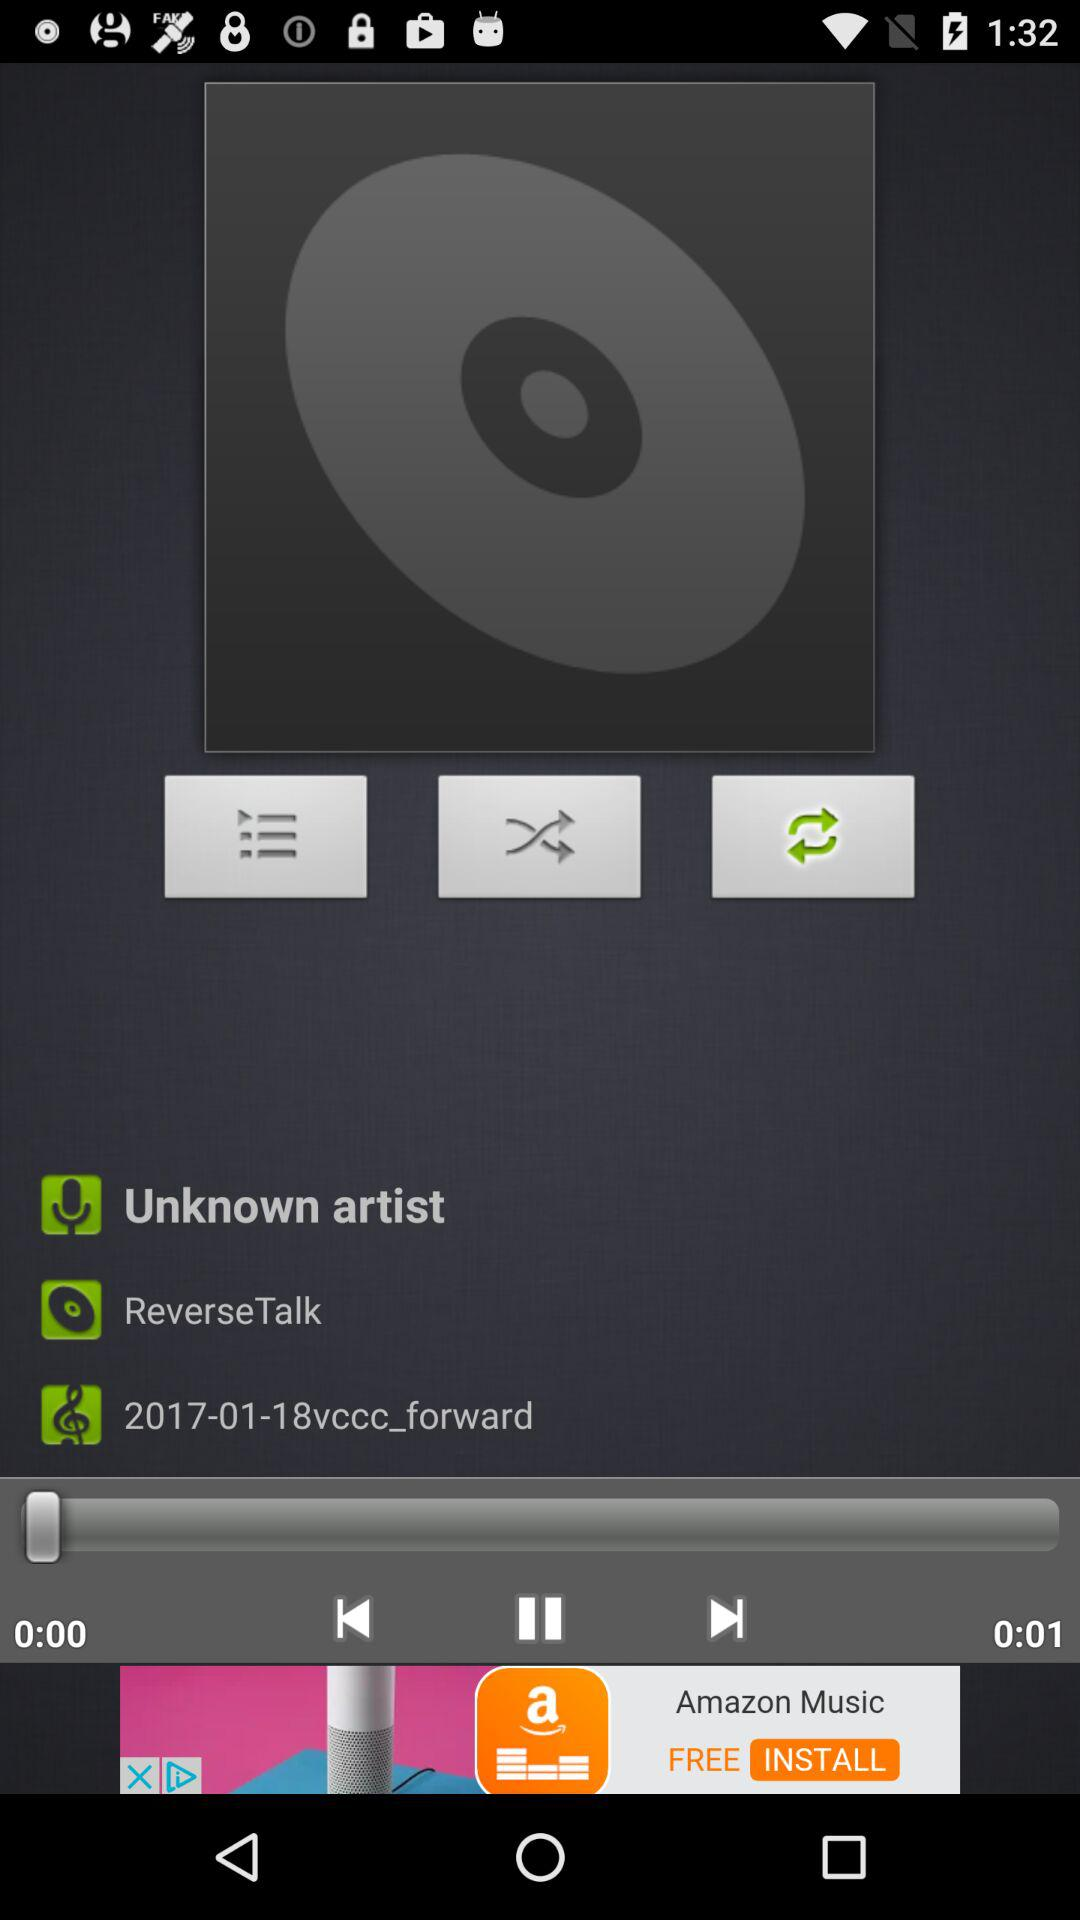How long is the audio clip?
Answer the question using a single word or phrase. 0:01 